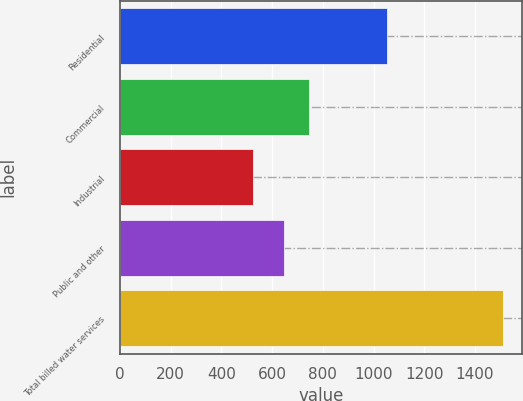<chart> <loc_0><loc_0><loc_500><loc_500><bar_chart><fcel>Residential<fcel>Commercial<fcel>Industrial<fcel>Public and other<fcel>Total billed water services<nl><fcel>1054<fcel>744.3<fcel>526<fcel>646<fcel>1509<nl></chart> 